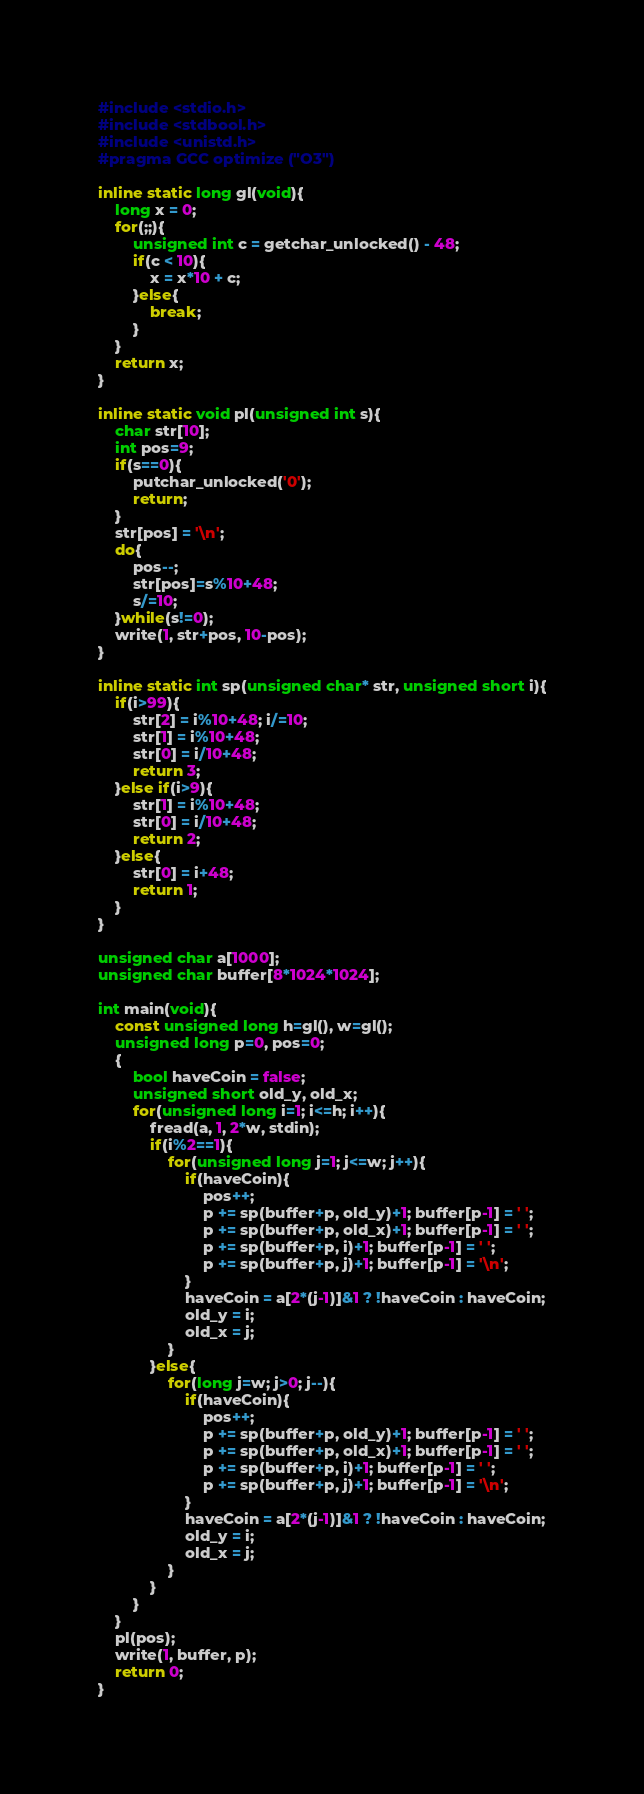<code> <loc_0><loc_0><loc_500><loc_500><_C_>#include <stdio.h>
#include <stdbool.h>
#include <unistd.h>
#pragma GCC optimize ("O3")

inline static long gl(void){
    long x = 0;
    for(;;){
        unsigned int c = getchar_unlocked() - 48;
        if(c < 10){
            x = x*10 + c;
        }else{
            break;
        }
    }
    return x;
}

inline static void pl(unsigned int s){
    char str[10];
    int pos=9;
    if(s==0){
        putchar_unlocked('0');
        return;
    }
    str[pos] = '\n';
    do{
        pos--;
        str[pos]=s%10+48;
        s/=10;
    }while(s!=0);
    write(1, str+pos, 10-pos);
}

inline static int sp(unsigned char* str, unsigned short i){
    if(i>99){
        str[2] = i%10+48; i/=10;
        str[1] = i%10+48;
        str[0] = i/10+48;
        return 3;
    }else if(i>9){
        str[1] = i%10+48;
        str[0] = i/10+48;
        return 2;
    }else{
        str[0] = i+48;
        return 1;
    }
}

unsigned char a[1000];
unsigned char buffer[8*1024*1024];

int main(void){
    const unsigned long h=gl(), w=gl();
    unsigned long p=0, pos=0;
    {
        bool haveCoin = false;
        unsigned short old_y, old_x;
        for(unsigned long i=1; i<=h; i++){
            fread(a, 1, 2*w, stdin);
            if(i%2==1){
                for(unsigned long j=1; j<=w; j++){
                    if(haveCoin){
                        pos++;
                        p += sp(buffer+p, old_y)+1; buffer[p-1] = ' '; 
                        p += sp(buffer+p, old_x)+1; buffer[p-1] = ' '; 
                        p += sp(buffer+p, i)+1; buffer[p-1] = ' '; 
                        p += sp(buffer+p, j)+1; buffer[p-1] = '\n';
                    }
                    haveCoin = a[2*(j-1)]&1 ? !haveCoin : haveCoin;
                    old_y = i;
                    old_x = j;
                }
            }else{
                for(long j=w; j>0; j--){
                    if(haveCoin){
                        pos++;
                        p += sp(buffer+p, old_y)+1; buffer[p-1] = ' '; 
                        p += sp(buffer+p, old_x)+1; buffer[p-1] = ' '; 
                        p += sp(buffer+p, i)+1; buffer[p-1] = ' '; 
                        p += sp(buffer+p, j)+1; buffer[p-1] = '\n';
                    }
                    haveCoin = a[2*(j-1)]&1 ? !haveCoin : haveCoin;
                    old_y = i;
                    old_x = j;
                }
            }
        }
    }
    pl(pos);
    write(1, buffer, p);
    return 0;
}
</code> 